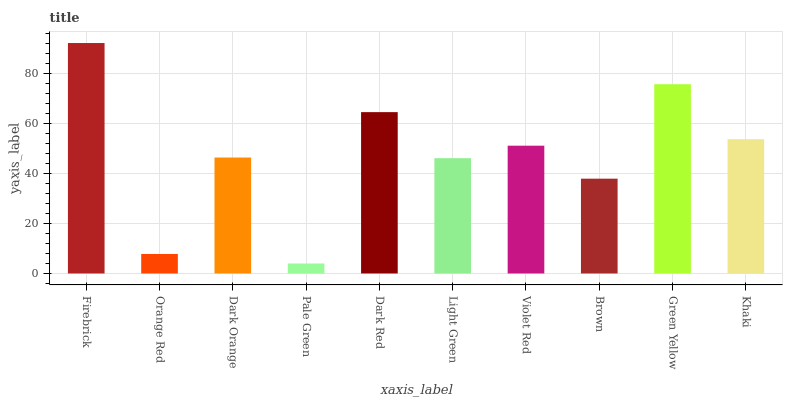Is Pale Green the minimum?
Answer yes or no. Yes. Is Firebrick the maximum?
Answer yes or no. Yes. Is Orange Red the minimum?
Answer yes or no. No. Is Orange Red the maximum?
Answer yes or no. No. Is Firebrick greater than Orange Red?
Answer yes or no. Yes. Is Orange Red less than Firebrick?
Answer yes or no. Yes. Is Orange Red greater than Firebrick?
Answer yes or no. No. Is Firebrick less than Orange Red?
Answer yes or no. No. Is Violet Red the high median?
Answer yes or no. Yes. Is Dark Orange the low median?
Answer yes or no. Yes. Is Green Yellow the high median?
Answer yes or no. No. Is Green Yellow the low median?
Answer yes or no. No. 